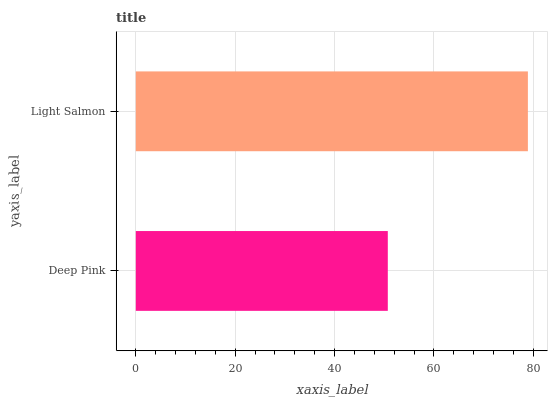Is Deep Pink the minimum?
Answer yes or no. Yes. Is Light Salmon the maximum?
Answer yes or no. Yes. Is Light Salmon the minimum?
Answer yes or no. No. Is Light Salmon greater than Deep Pink?
Answer yes or no. Yes. Is Deep Pink less than Light Salmon?
Answer yes or no. Yes. Is Deep Pink greater than Light Salmon?
Answer yes or no. No. Is Light Salmon less than Deep Pink?
Answer yes or no. No. Is Light Salmon the high median?
Answer yes or no. Yes. Is Deep Pink the low median?
Answer yes or no. Yes. Is Deep Pink the high median?
Answer yes or no. No. Is Light Salmon the low median?
Answer yes or no. No. 